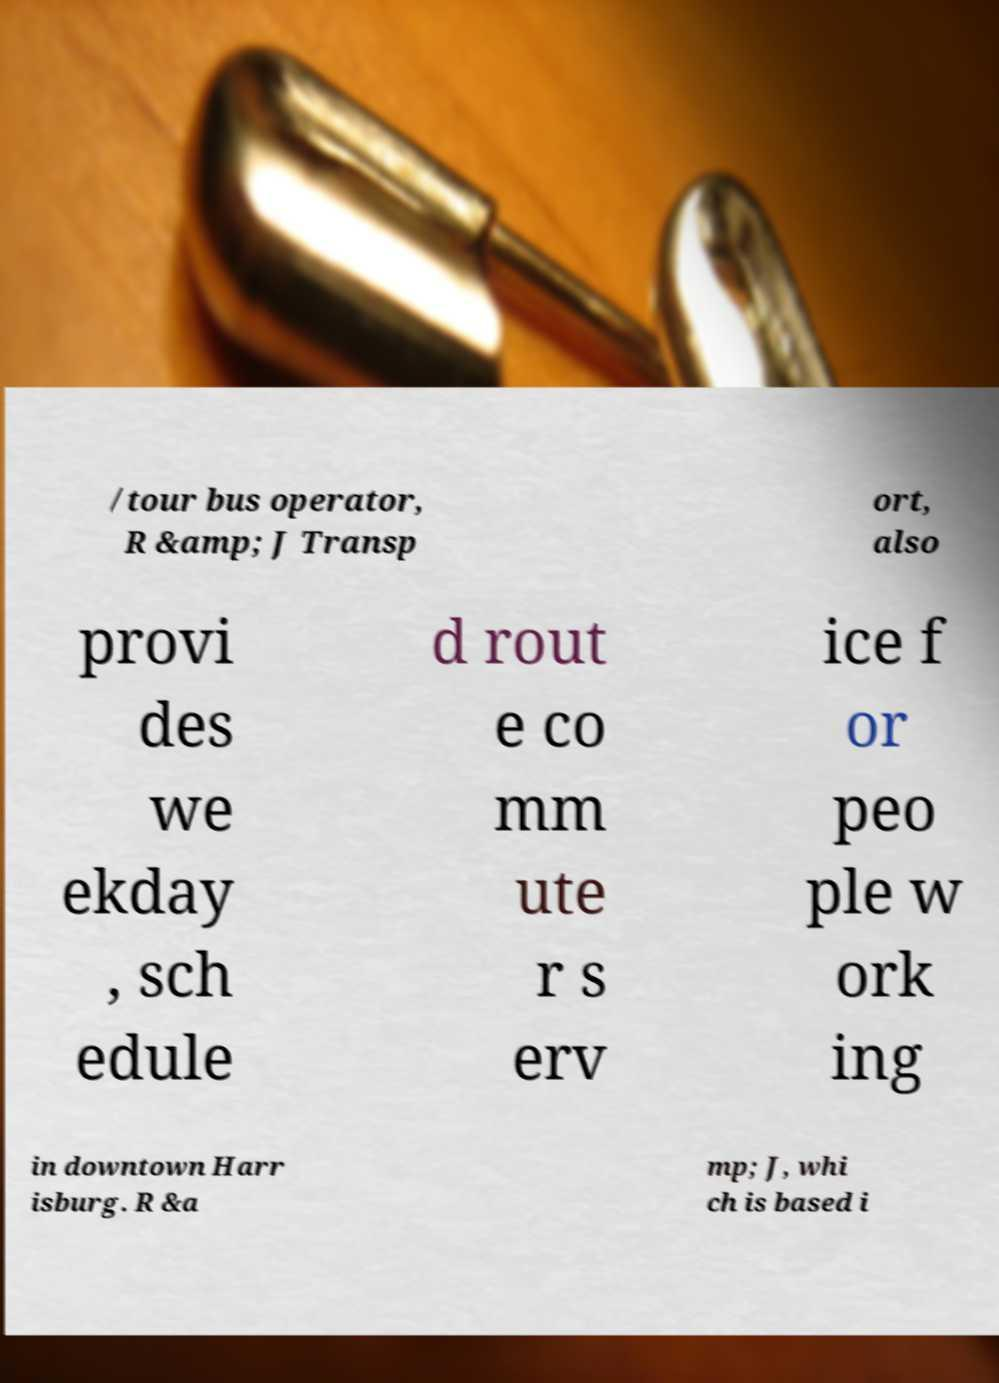Could you assist in decoding the text presented in this image and type it out clearly? /tour bus operator, R &amp; J Transp ort, also provi des we ekday , sch edule d rout e co mm ute r s erv ice f or peo ple w ork ing in downtown Harr isburg. R &a mp; J, whi ch is based i 